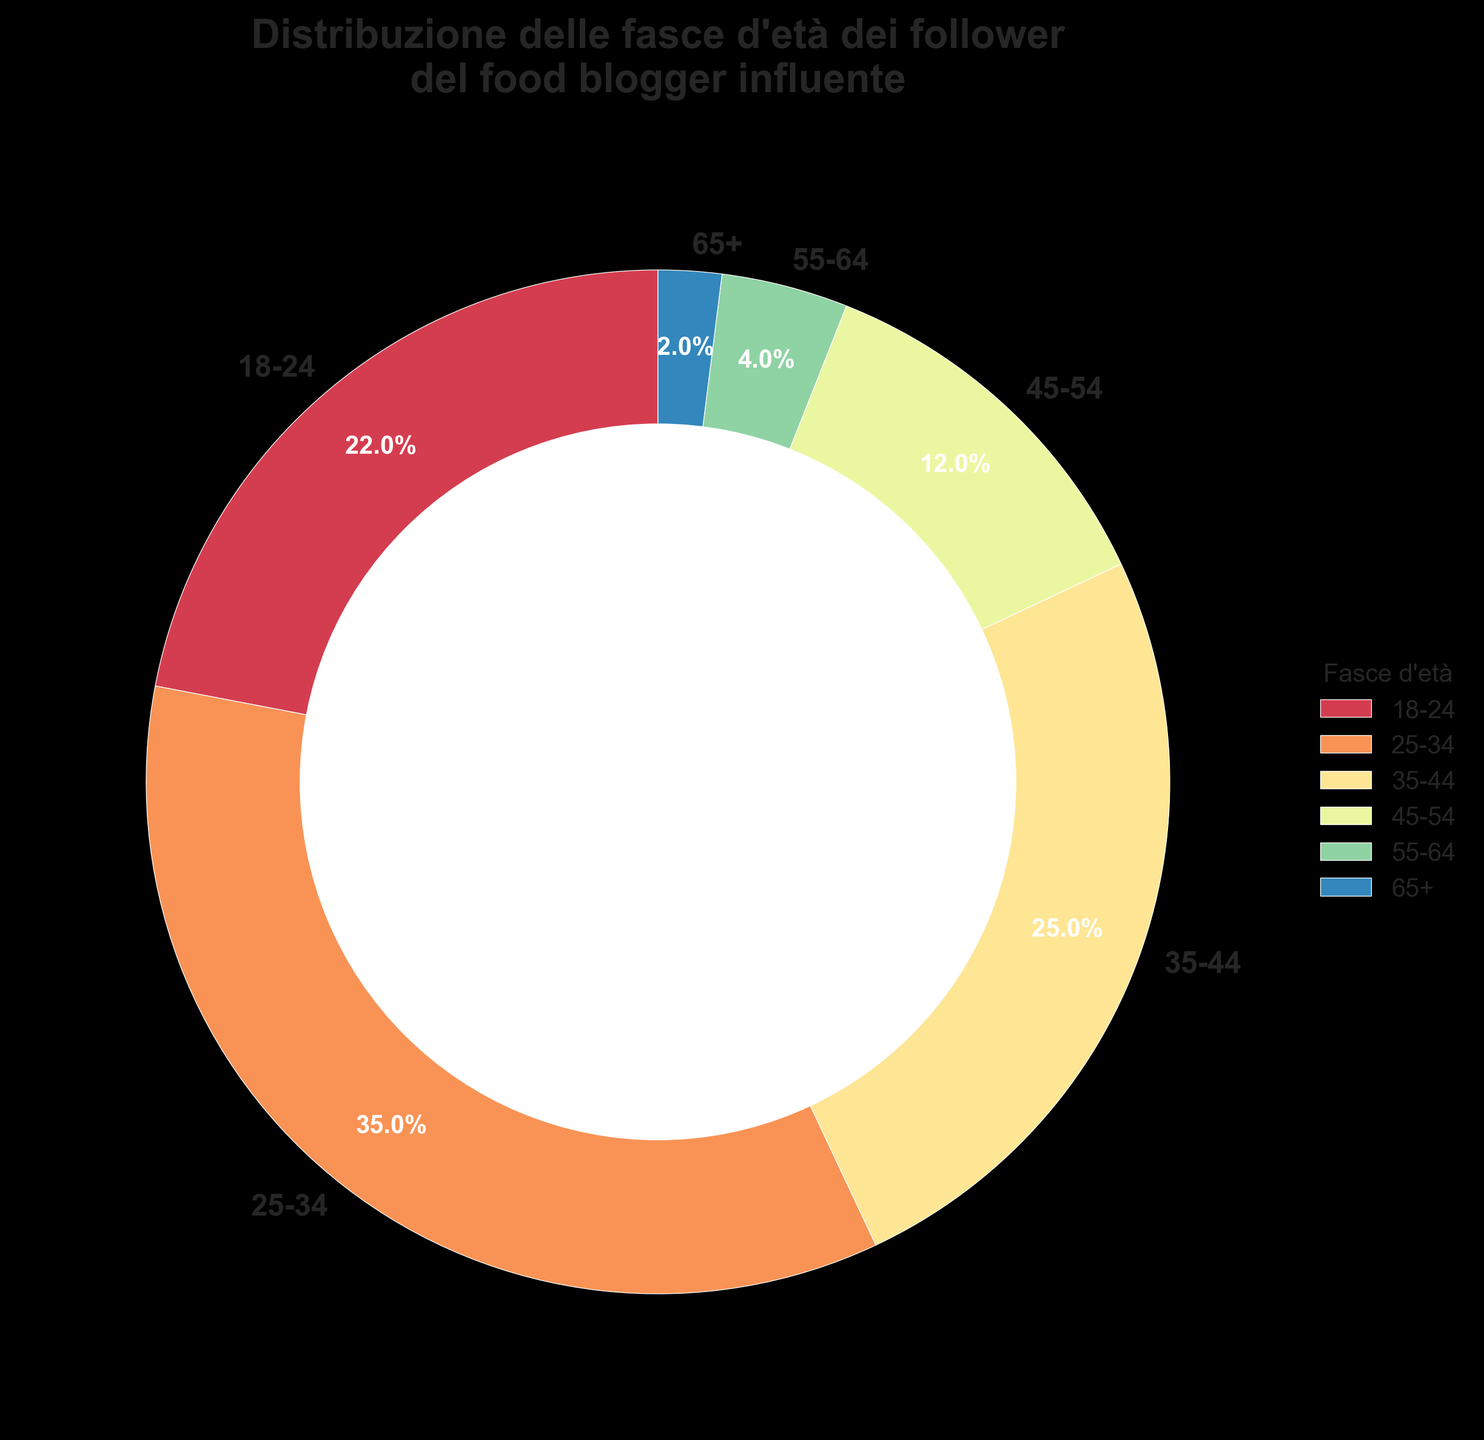Which age group has the largest percentage of followers? The chart shows the percentages of different age groups, and the largest segment corresponds to the 25-34 age group, which has the highest percentage at 35%.
Answer: 25-34 Which age group has the smallest percentage of followers? The chart shows the percentages of different age groups, and the 65+ age group has the smallest percentage at 2%.
Answer: 65+ What is the combined percentage of followers aged 35 and above? Sum the percentages of the 35-44, 45-54, 55-64, and 65+ age groups: 25% + 12% + 4% + 2% = 43%.
Answer: 43% Are there more followers in the 18-24 age group or the 35-44 age group? Compare the percentages: the 18-24 age group has 22%, while the 35-44 age group has 25%.
Answer: 35-44 What is the percentage difference between the 25-34 and 45-54 age groups? Subtract the percentage of the 45-54 age group from the 25-34 age group: 35% - 12% = 23%.
Answer: 23% What is the visual color of the 55-64 age group segment? The chart uses a gradient color scheme, and the 55-64 age group segment is represented by a lighter color towards the legend.
Answer: Light color Does the combined percentage of followers aged 18-34 exceed 50%? Add the percentages of the 18-24 and 25-34 age groups: 22% + 35% = 57%, which indeed exceeds 50%.
Answer: Yes How many age groups have a percentage of followers less than 10%? The chart shows three age groups (45-54, 55-64, 65+) with percentages of 12%, 4%, and 2%. Only 55-64 and 65+ are below 10%, hence two age groups.
Answer: 2 Is the percentage difference between the largest and smallest age groups greater than 30%? Subtract the smallest age group's percentage (65+ with 2%) from the largest (25-34 with 35%): 35% - 2% = 33%.
Answer: Yes Which age groups have a percentage of followers in the double digits? The chart shows that the age groups with percentages in the double digits are 18-24 (22%), 25-34 (35%), 35-44 (25%), and 45-54 (12%).
Answer: 18-24, 25-34, 35-44, 45-54 